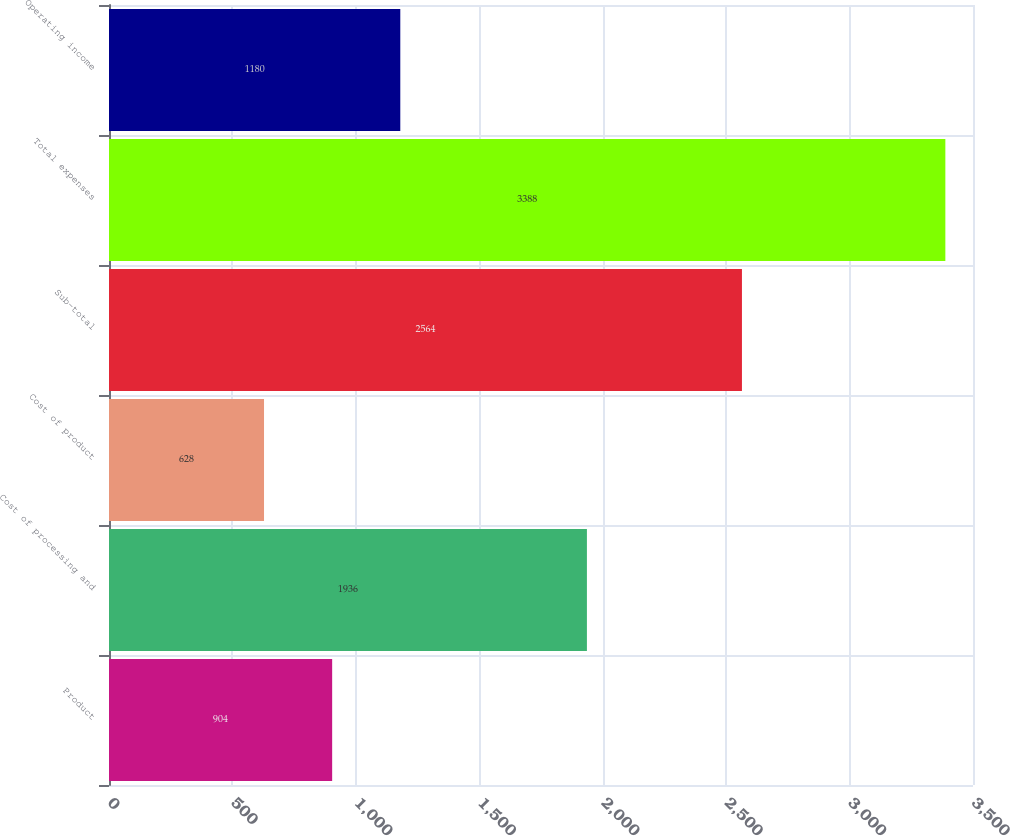Convert chart. <chart><loc_0><loc_0><loc_500><loc_500><bar_chart><fcel>Product<fcel>Cost of processing and<fcel>Cost of product<fcel>Sub-total<fcel>Total expenses<fcel>Operating income<nl><fcel>904<fcel>1936<fcel>628<fcel>2564<fcel>3388<fcel>1180<nl></chart> 